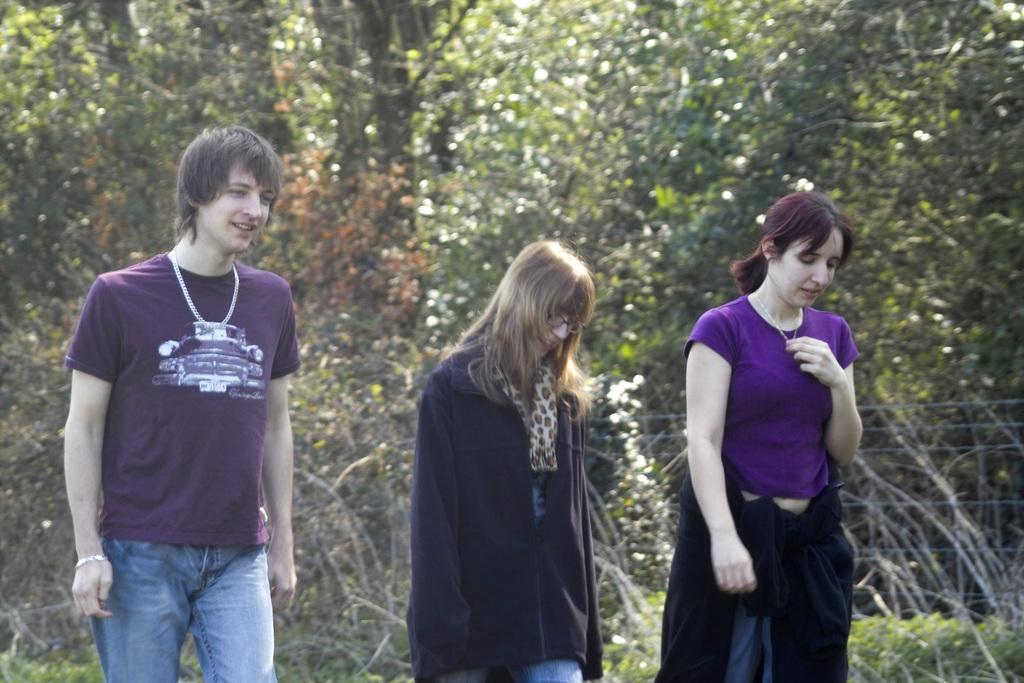Describe this image in one or two sentences. There are two women and the man standing. I think this is the fence. In the background, I can see the trees with branches and leaves. 